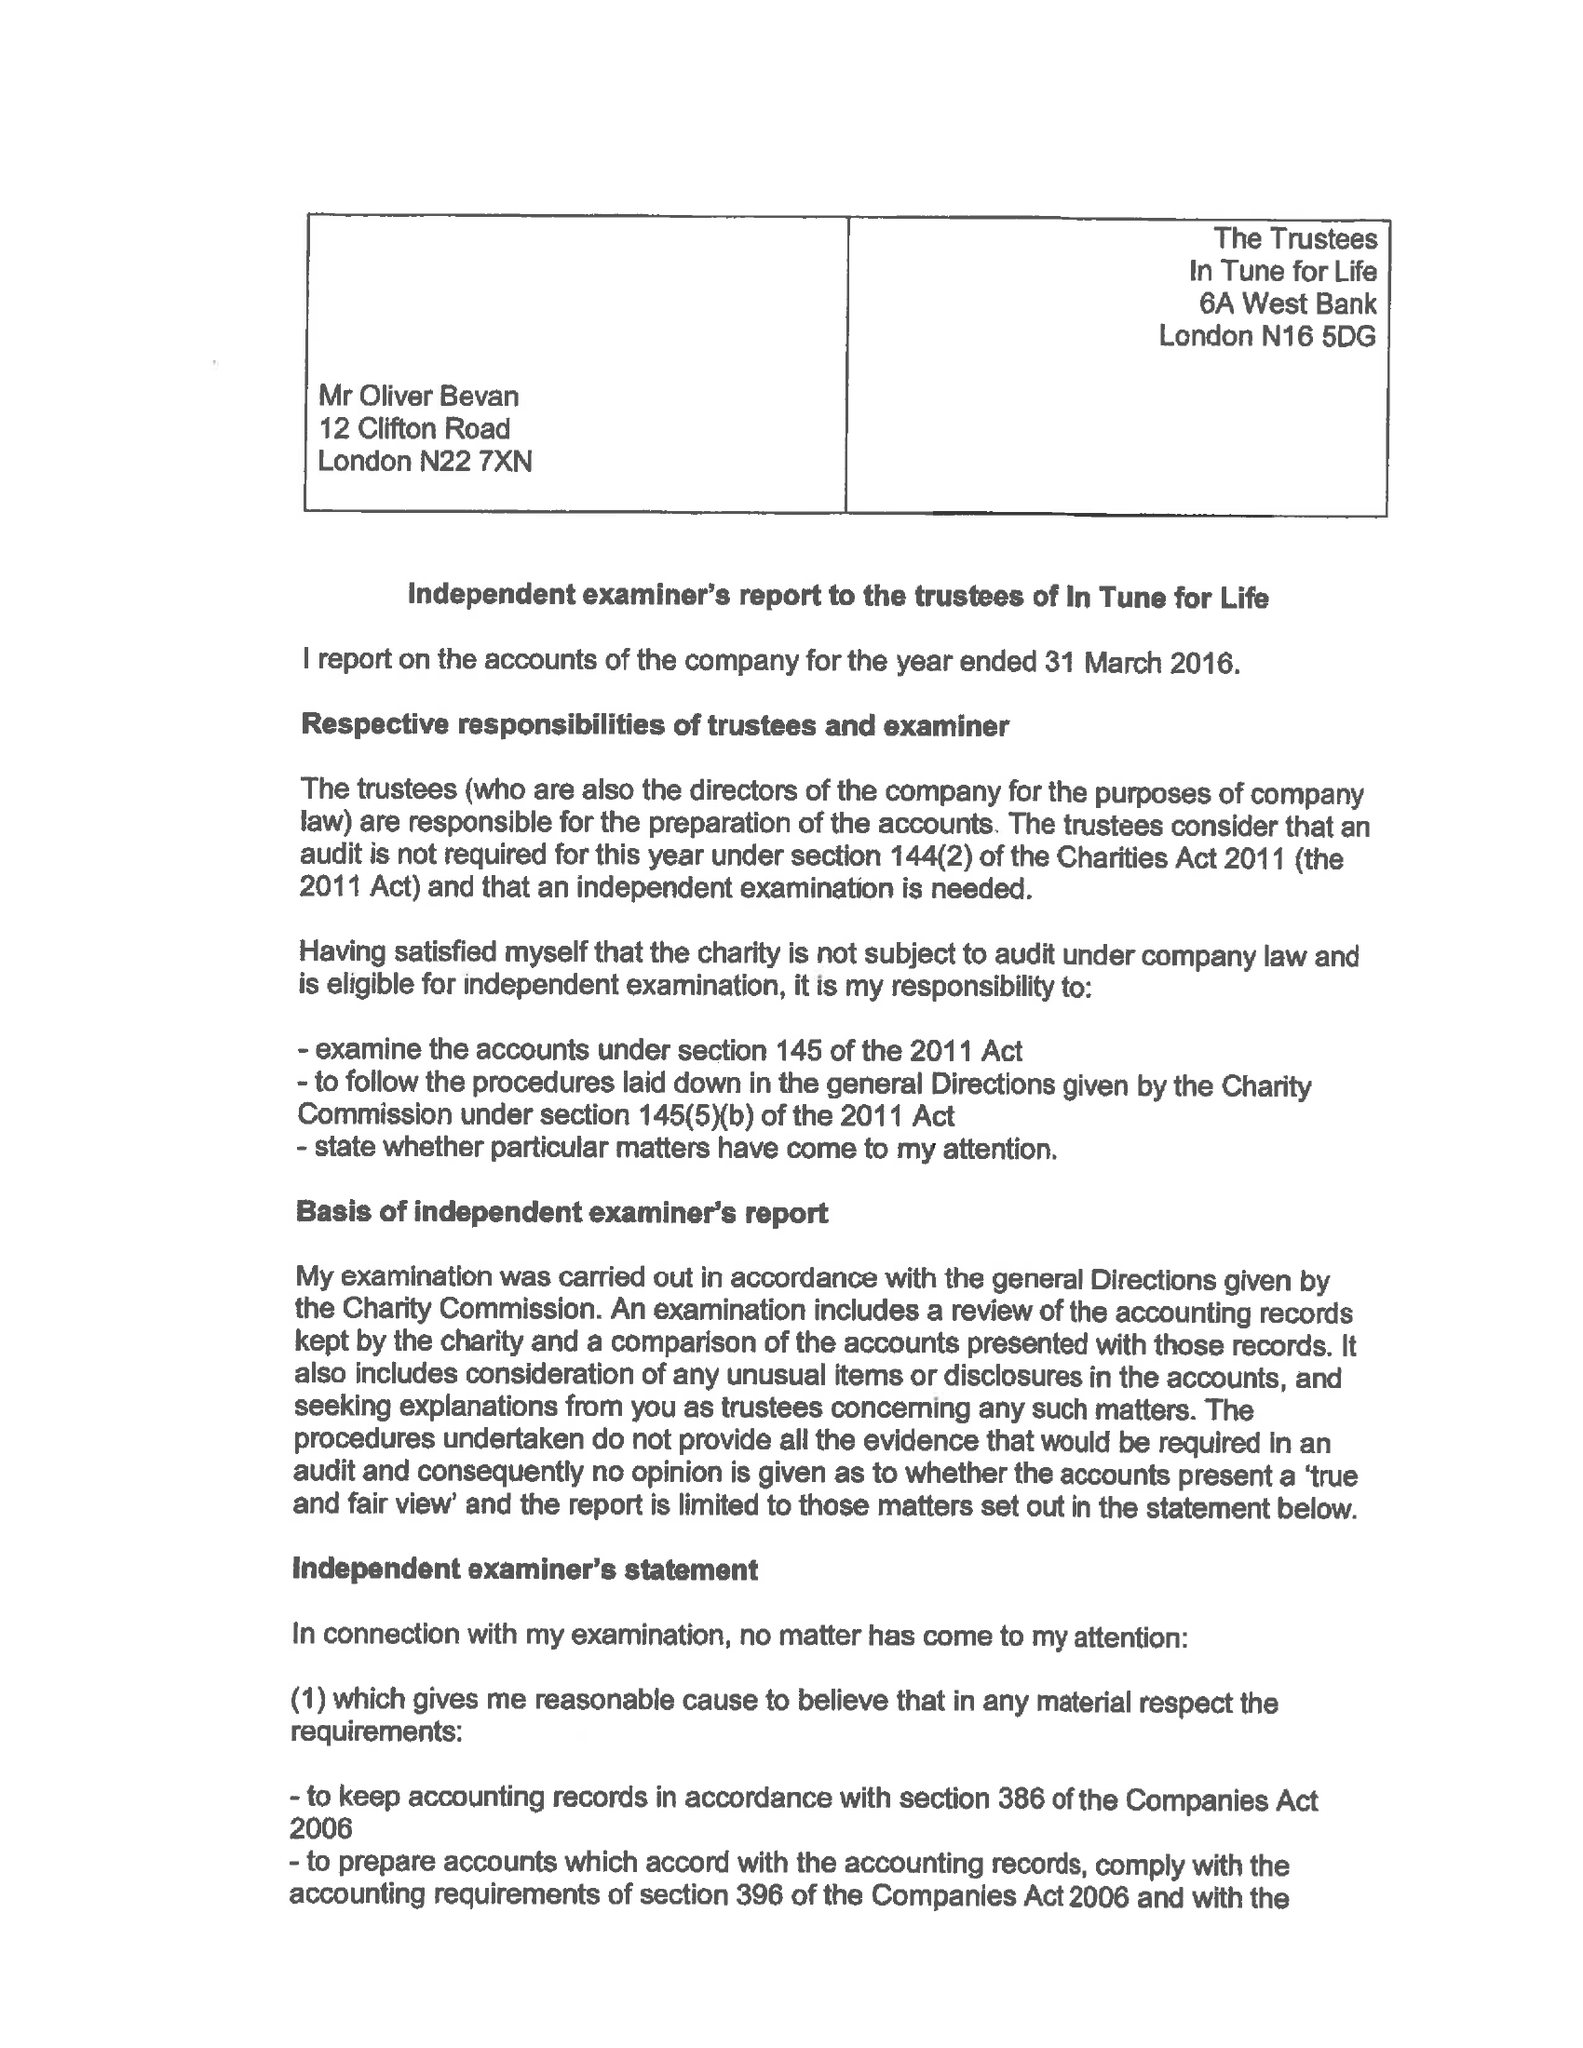What is the value for the charity_name?
Answer the question using a single word or phrase. In Tune For Life 